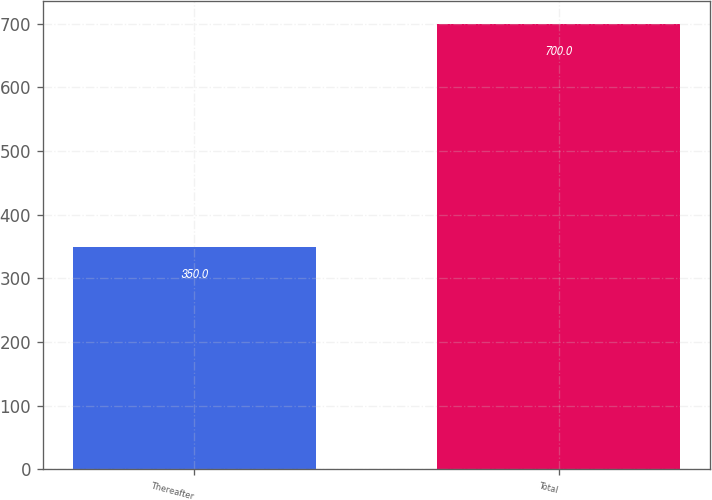Convert chart. <chart><loc_0><loc_0><loc_500><loc_500><bar_chart><fcel>Thereafter<fcel>Total<nl><fcel>350<fcel>700<nl></chart> 